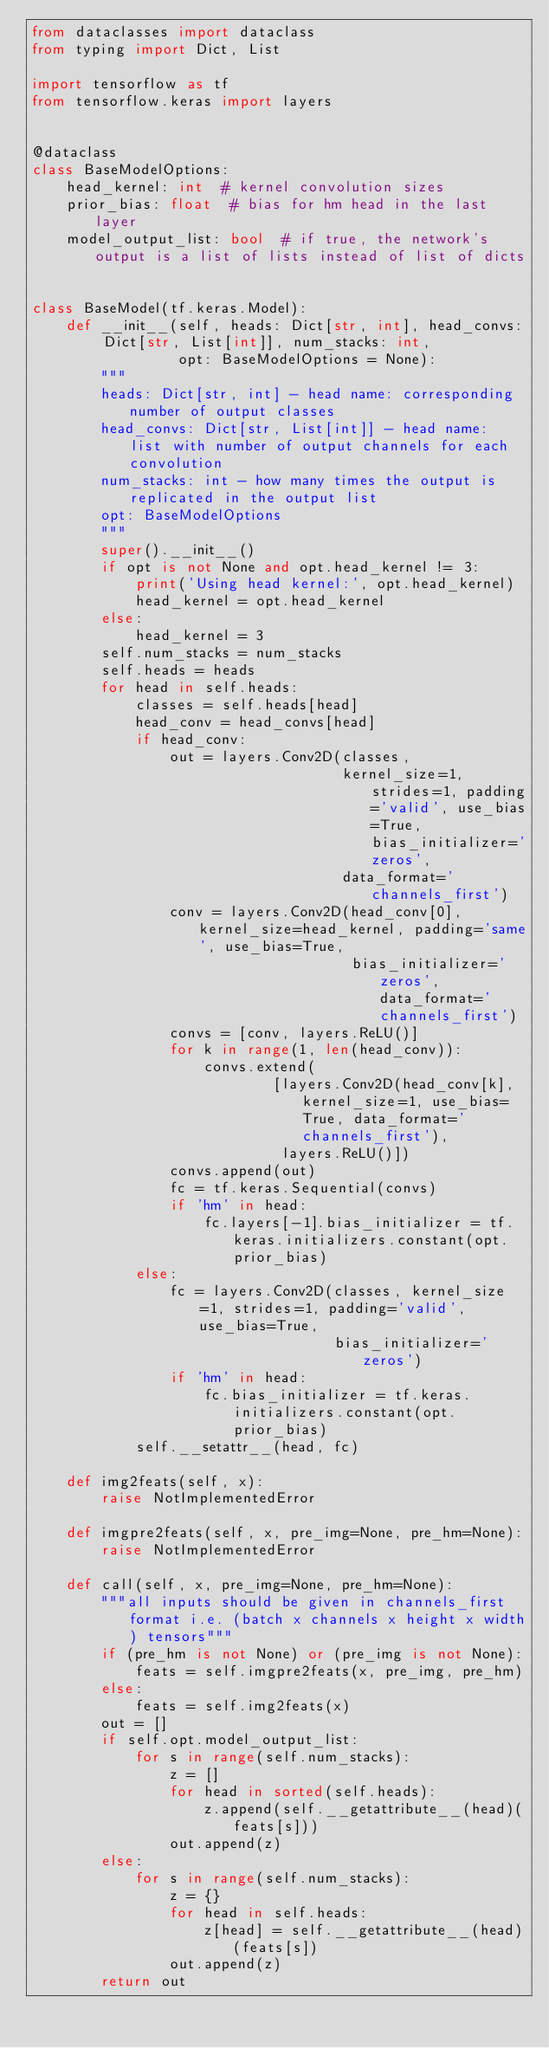Convert code to text. <code><loc_0><loc_0><loc_500><loc_500><_Python_>from dataclasses import dataclass
from typing import Dict, List

import tensorflow as tf
from tensorflow.keras import layers


@dataclass
class BaseModelOptions:
    head_kernel: int  # kernel convolution sizes
    prior_bias: float  # bias for hm head in the last layer
    model_output_list: bool  # if true, the network's output is a list of lists instead of list of dicts


class BaseModel(tf.keras.Model):
    def __init__(self, heads: Dict[str, int], head_convs: Dict[str, List[int]], num_stacks: int,
                 opt: BaseModelOptions = None):
        """
        heads: Dict[str, int] - head name: corresponding number of output classes
        head_convs: Dict[str, List[int]] - head name: list with number of output channels for each convolution
        num_stacks: int - how many times the output is replicated in the output list
        opt: BaseModelOptions
        """
        super().__init__()
        if opt is not None and opt.head_kernel != 3:
            print('Using head kernel:', opt.head_kernel)
            head_kernel = opt.head_kernel
        else:
            head_kernel = 3
        self.num_stacks = num_stacks
        self.heads = heads
        for head in self.heads:
            classes = self.heads[head]
            head_conv = head_convs[head]
            if head_conv:
                out = layers.Conv2D(classes,
                                    kernel_size=1, strides=1, padding='valid', use_bias=True, bias_initializer='zeros',
                                    data_format='channels_first')
                conv = layers.Conv2D(head_conv[0], kernel_size=head_kernel, padding='same', use_bias=True,
                                     bias_initializer='zeros', data_format='channels_first')
                convs = [conv, layers.ReLU()]
                for k in range(1, len(head_conv)):
                    convs.extend(
                            [layers.Conv2D(head_conv[k], kernel_size=1, use_bias=True, data_format='channels_first'),
                             layers.ReLU()])
                convs.append(out)
                fc = tf.keras.Sequential(convs)
                if 'hm' in head:
                    fc.layers[-1].bias_initializer = tf.keras.initializers.constant(opt.prior_bias)
            else:
                fc = layers.Conv2D(classes, kernel_size=1, strides=1, padding='valid', use_bias=True,
                                   bias_initializer='zeros')
                if 'hm' in head:
                    fc.bias_initializer = tf.keras.initializers.constant(opt.prior_bias)
            self.__setattr__(head, fc)

    def img2feats(self, x):
        raise NotImplementedError

    def imgpre2feats(self, x, pre_img=None, pre_hm=None):
        raise NotImplementedError

    def call(self, x, pre_img=None, pre_hm=None):
        """all inputs should be given in channels_first format i.e. (batch x channels x height x width) tensors"""
        if (pre_hm is not None) or (pre_img is not None):
            feats = self.imgpre2feats(x, pre_img, pre_hm)
        else:
            feats = self.img2feats(x)
        out = []
        if self.opt.model_output_list:
            for s in range(self.num_stacks):
                z = []
                for head in sorted(self.heads):
                    z.append(self.__getattribute__(head)(feats[s]))
                out.append(z)
        else:
            for s in range(self.num_stacks):
                z = {}
                for head in self.heads:
                    z[head] = self.__getattribute__(head)(feats[s])
                out.append(z)
        return out
</code> 